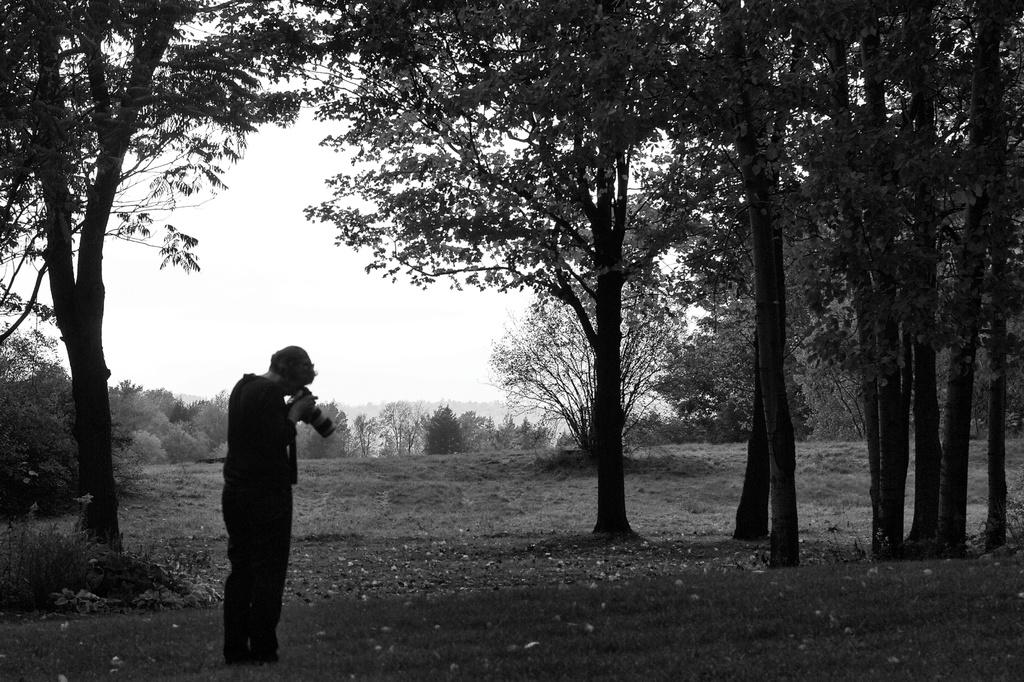What is the person in the image doing? The person is standing in the image and holding a camera. What can be seen in the image besides the person? There are trees in the image, and the sky is visible in the background. What type of crayon is the person using to draw in the image? There is no crayon present in the image, and the person is holding a camera, not a crayon. What meal is being prepared in the image? There is no meal preparation visible in the image; it primarily features a person holding a camera and the surrounding environment. 